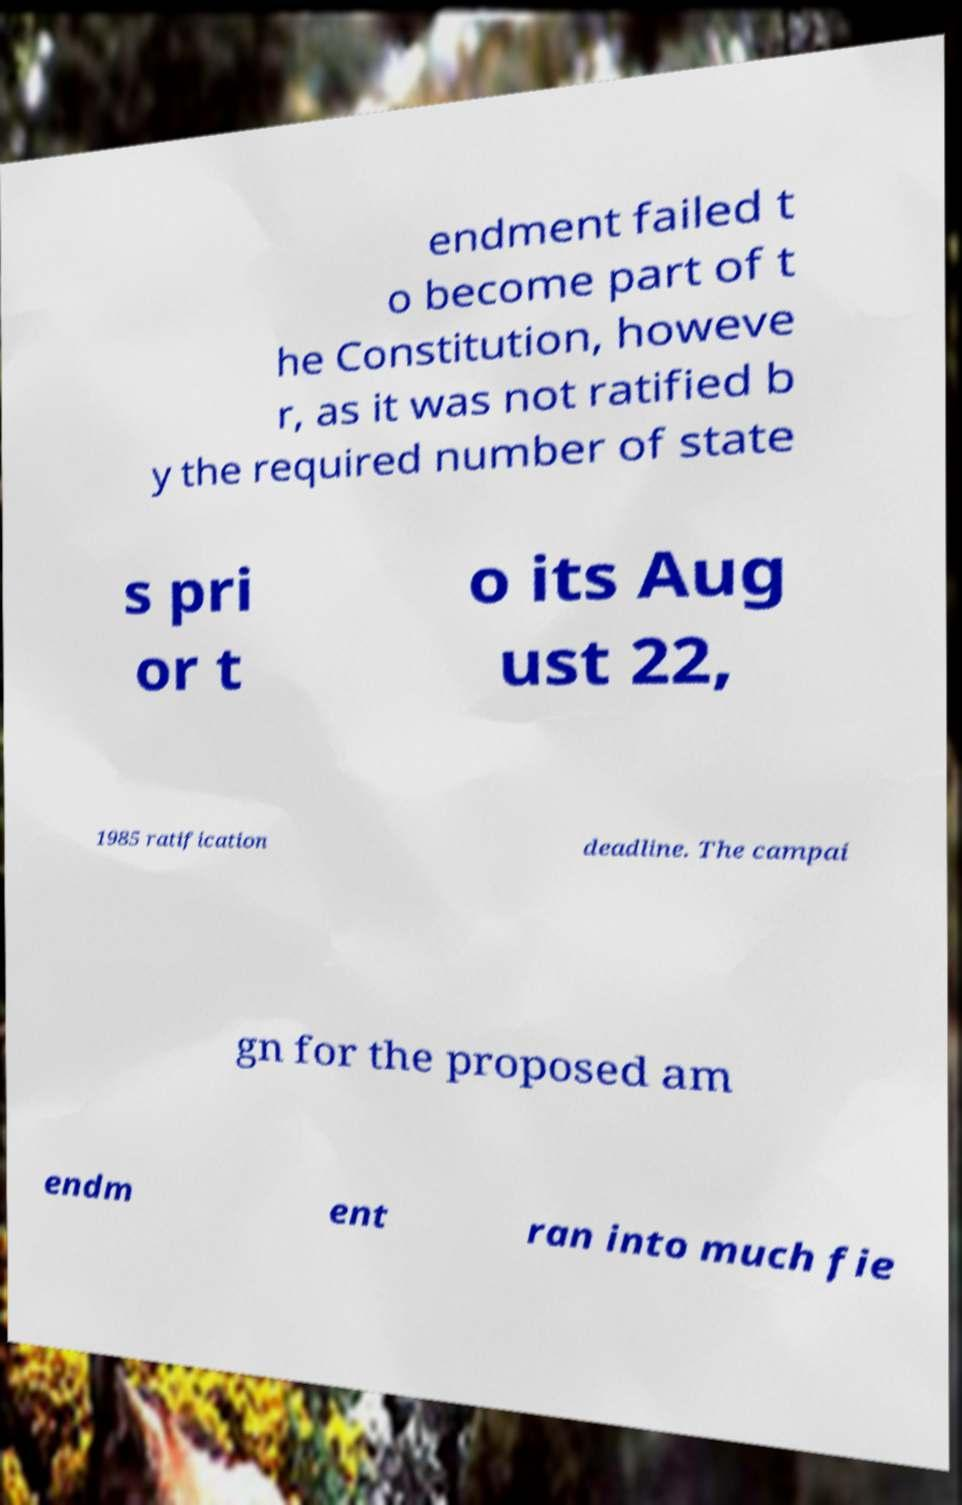Could you assist in decoding the text presented in this image and type it out clearly? endment failed t o become part of t he Constitution, howeve r, as it was not ratified b y the required number of state s pri or t o its Aug ust 22, 1985 ratification deadline. The campai gn for the proposed am endm ent ran into much fie 